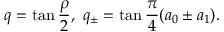<formula> <loc_0><loc_0><loc_500><loc_500>q = \tan \frac { \rho } { 2 } , \ q _ { \pm } = \tan \frac { \pi } { 4 } ( a _ { 0 } \pm a _ { 1 } ) .</formula> 